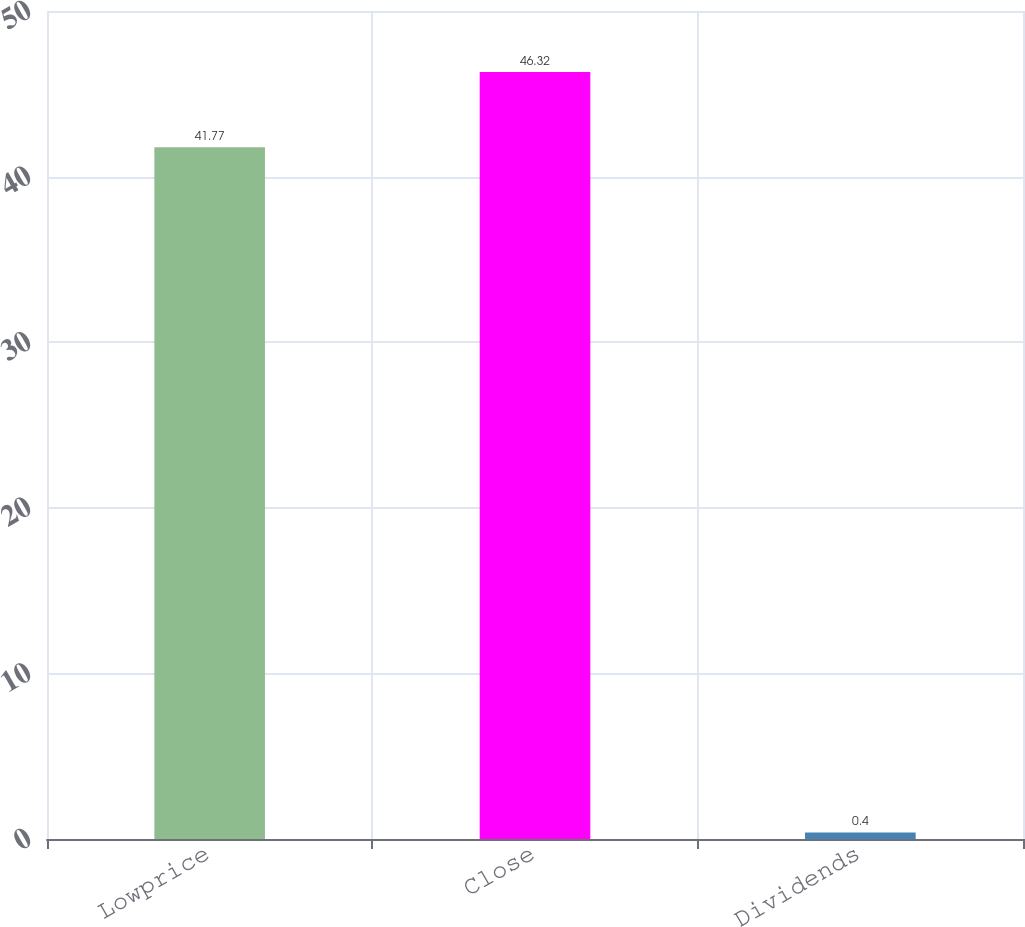<chart> <loc_0><loc_0><loc_500><loc_500><bar_chart><fcel>Lowprice<fcel>Close<fcel>Dividends<nl><fcel>41.77<fcel>46.32<fcel>0.4<nl></chart> 